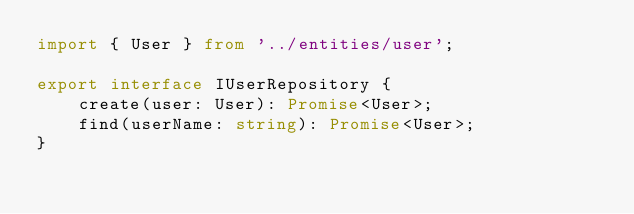Convert code to text. <code><loc_0><loc_0><loc_500><loc_500><_TypeScript_>import { User } from '../entities/user';

export interface IUserRepository {
    create(user: User): Promise<User>;
    find(userName: string): Promise<User>;
}
</code> 